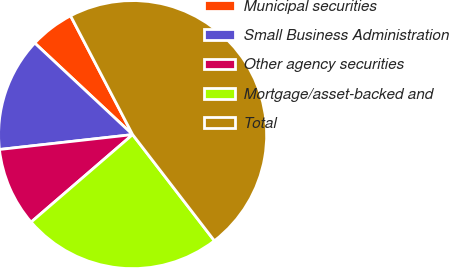<chart> <loc_0><loc_0><loc_500><loc_500><pie_chart><fcel>Municipal securities<fcel>Small Business Administration<fcel>Other agency securities<fcel>Mortgage/asset-backed and<fcel>Total<nl><fcel>5.37%<fcel>13.74%<fcel>9.55%<fcel>24.12%<fcel>47.22%<nl></chart> 